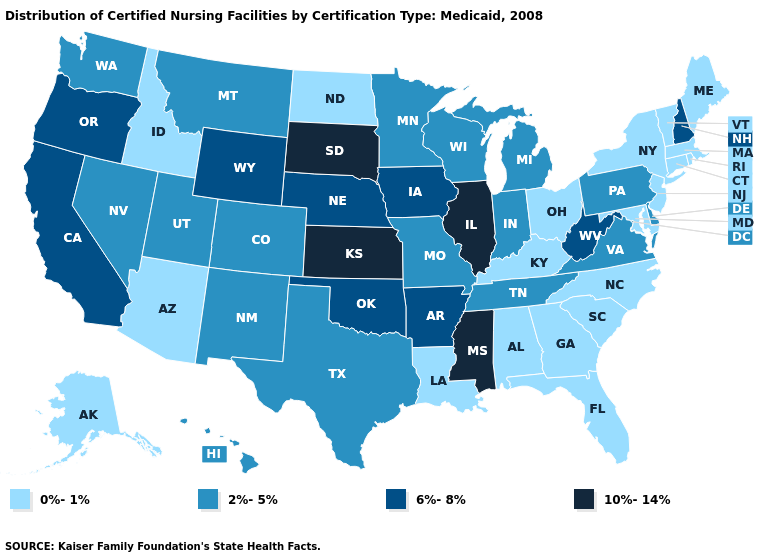What is the highest value in the Northeast ?
Keep it brief. 6%-8%. What is the value of Minnesota?
Write a very short answer. 2%-5%. What is the highest value in the USA?
Be succinct. 10%-14%. Among the states that border Missouri , which have the lowest value?
Keep it brief. Kentucky. Does Hawaii have the same value as Nevada?
Be succinct. Yes. Name the states that have a value in the range 10%-14%?
Quick response, please. Illinois, Kansas, Mississippi, South Dakota. Does Kansas have the highest value in the USA?
Quick response, please. Yes. Which states have the highest value in the USA?
Quick response, please. Illinois, Kansas, Mississippi, South Dakota. Does Kentucky have the same value as Oklahoma?
Be succinct. No. What is the value of Hawaii?
Keep it brief. 2%-5%. What is the highest value in the USA?
Write a very short answer. 10%-14%. How many symbols are there in the legend?
Give a very brief answer. 4. Among the states that border Iowa , which have the lowest value?
Write a very short answer. Minnesota, Missouri, Wisconsin. Does the map have missing data?
Concise answer only. No. Does Alabama have the highest value in the USA?
Concise answer only. No. 